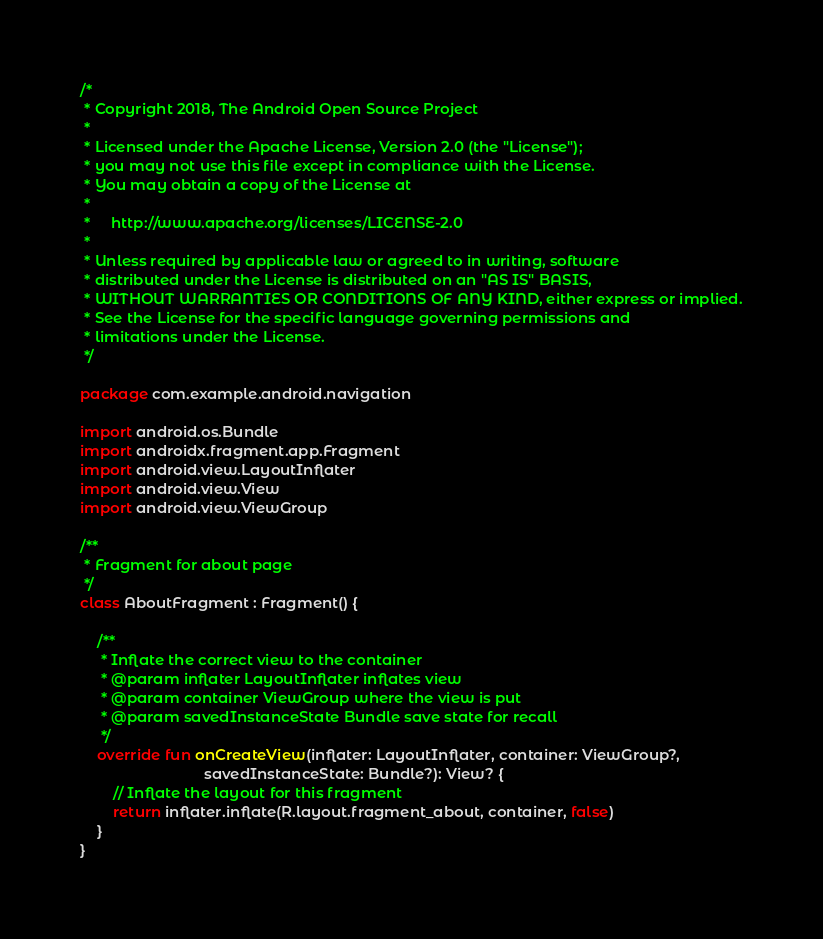<code> <loc_0><loc_0><loc_500><loc_500><_Kotlin_>/*
 * Copyright 2018, The Android Open Source Project
 *
 * Licensed under the Apache License, Version 2.0 (the "License");
 * you may not use this file except in compliance with the License.
 * You may obtain a copy of the License at
 *
 *     http://www.apache.org/licenses/LICENSE-2.0
 *
 * Unless required by applicable law or agreed to in writing, software
 * distributed under the License is distributed on an "AS IS" BASIS,
 * WITHOUT WARRANTIES OR CONDITIONS OF ANY KIND, either express or implied.
 * See the License for the specific language governing permissions and
 * limitations under the License.
 */

package com.example.android.navigation

import android.os.Bundle
import androidx.fragment.app.Fragment
import android.view.LayoutInflater
import android.view.View
import android.view.ViewGroup

/**
 * Fragment for about page
 */
class AboutFragment : Fragment() {

    /**
     * Inflate the correct view to the container
     * @param inflater LayoutInflater inflates view
     * @param container ViewGroup where the view is put
     * @param savedInstanceState Bundle save state for recall
     */
    override fun onCreateView(inflater: LayoutInflater, container: ViewGroup?,
                              savedInstanceState: Bundle?): View? {
        // Inflate the layout for this fragment
        return inflater.inflate(R.layout.fragment_about, container, false)
    }
}
</code> 